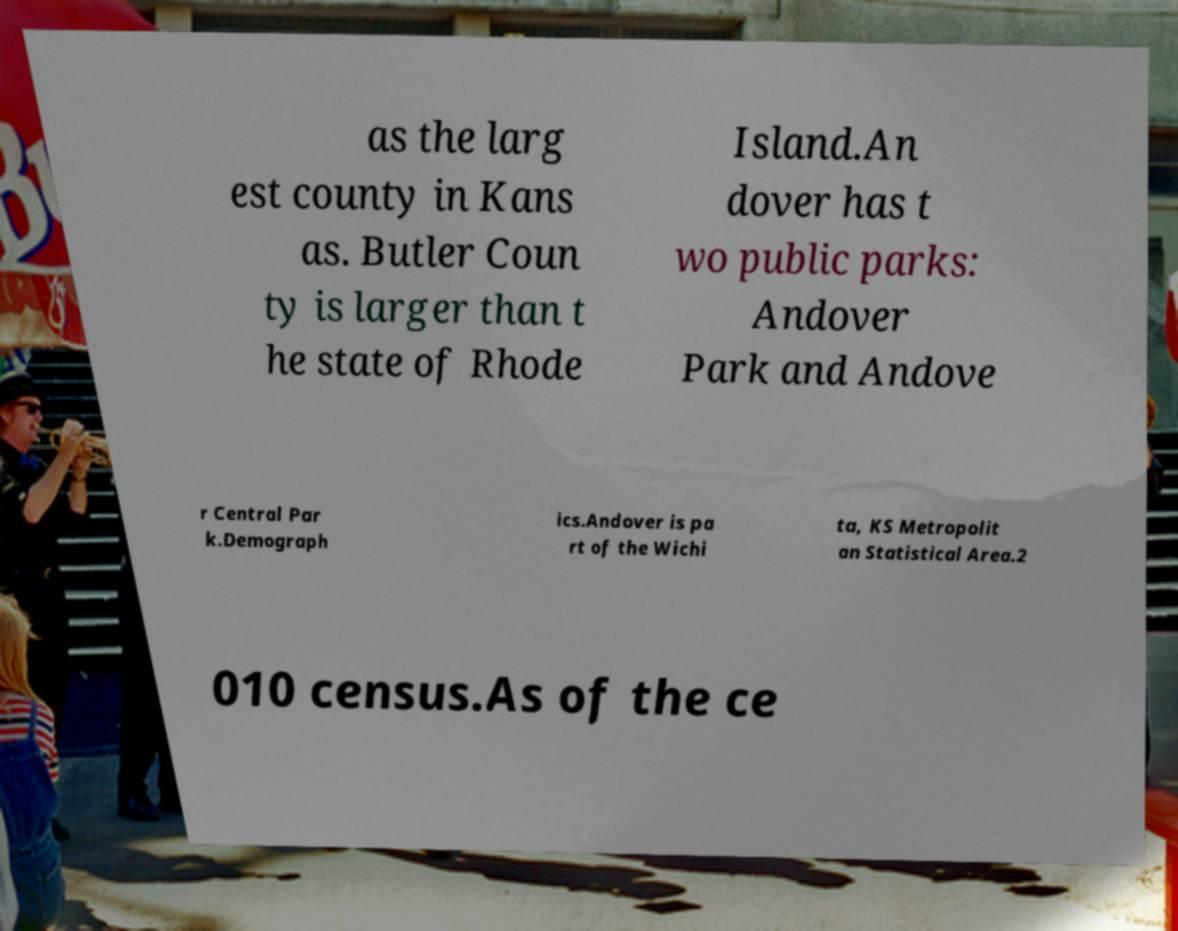Can you read and provide the text displayed in the image?This photo seems to have some interesting text. Can you extract and type it out for me? as the larg est county in Kans as. Butler Coun ty is larger than t he state of Rhode Island.An dover has t wo public parks: Andover Park and Andove r Central Par k.Demograph ics.Andover is pa rt of the Wichi ta, KS Metropolit an Statistical Area.2 010 census.As of the ce 